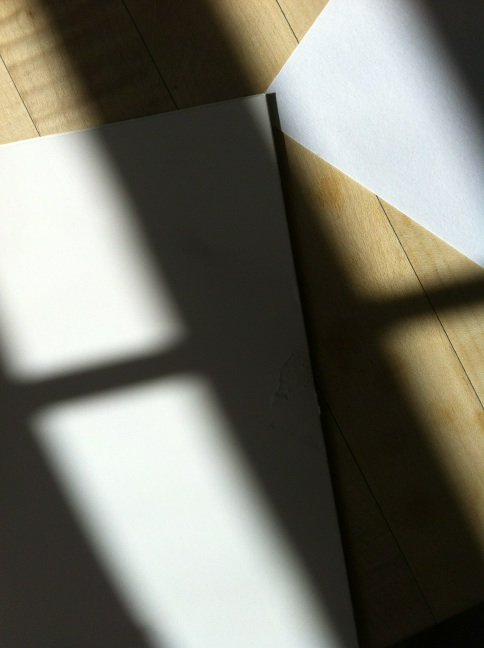Can you find a key code for office 2010 on this side of the jacket? The image does not show any text or numbers that could be interpreted as a key code for Office 2010. It's focused solely on a jacket edge with light and shadow interactions, lacking any discernible patterns or codes. If you're looking for a key code on a physical item like a jacket, it would typically be on a tag or label, perhaps inside the lining. Checking there or considering other locations for such information might be fruitful. 